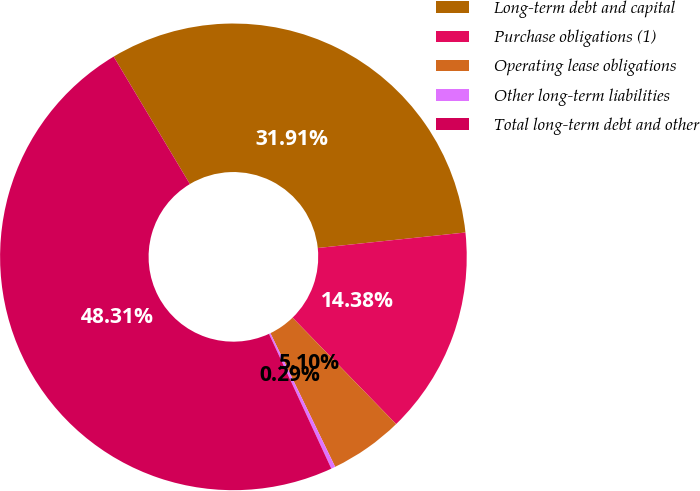Convert chart. <chart><loc_0><loc_0><loc_500><loc_500><pie_chart><fcel>Long-term debt and capital<fcel>Purchase obligations (1)<fcel>Operating lease obligations<fcel>Other long-term liabilities<fcel>Total long-term debt and other<nl><fcel>31.91%<fcel>14.38%<fcel>5.1%<fcel>0.29%<fcel>48.31%<nl></chart> 